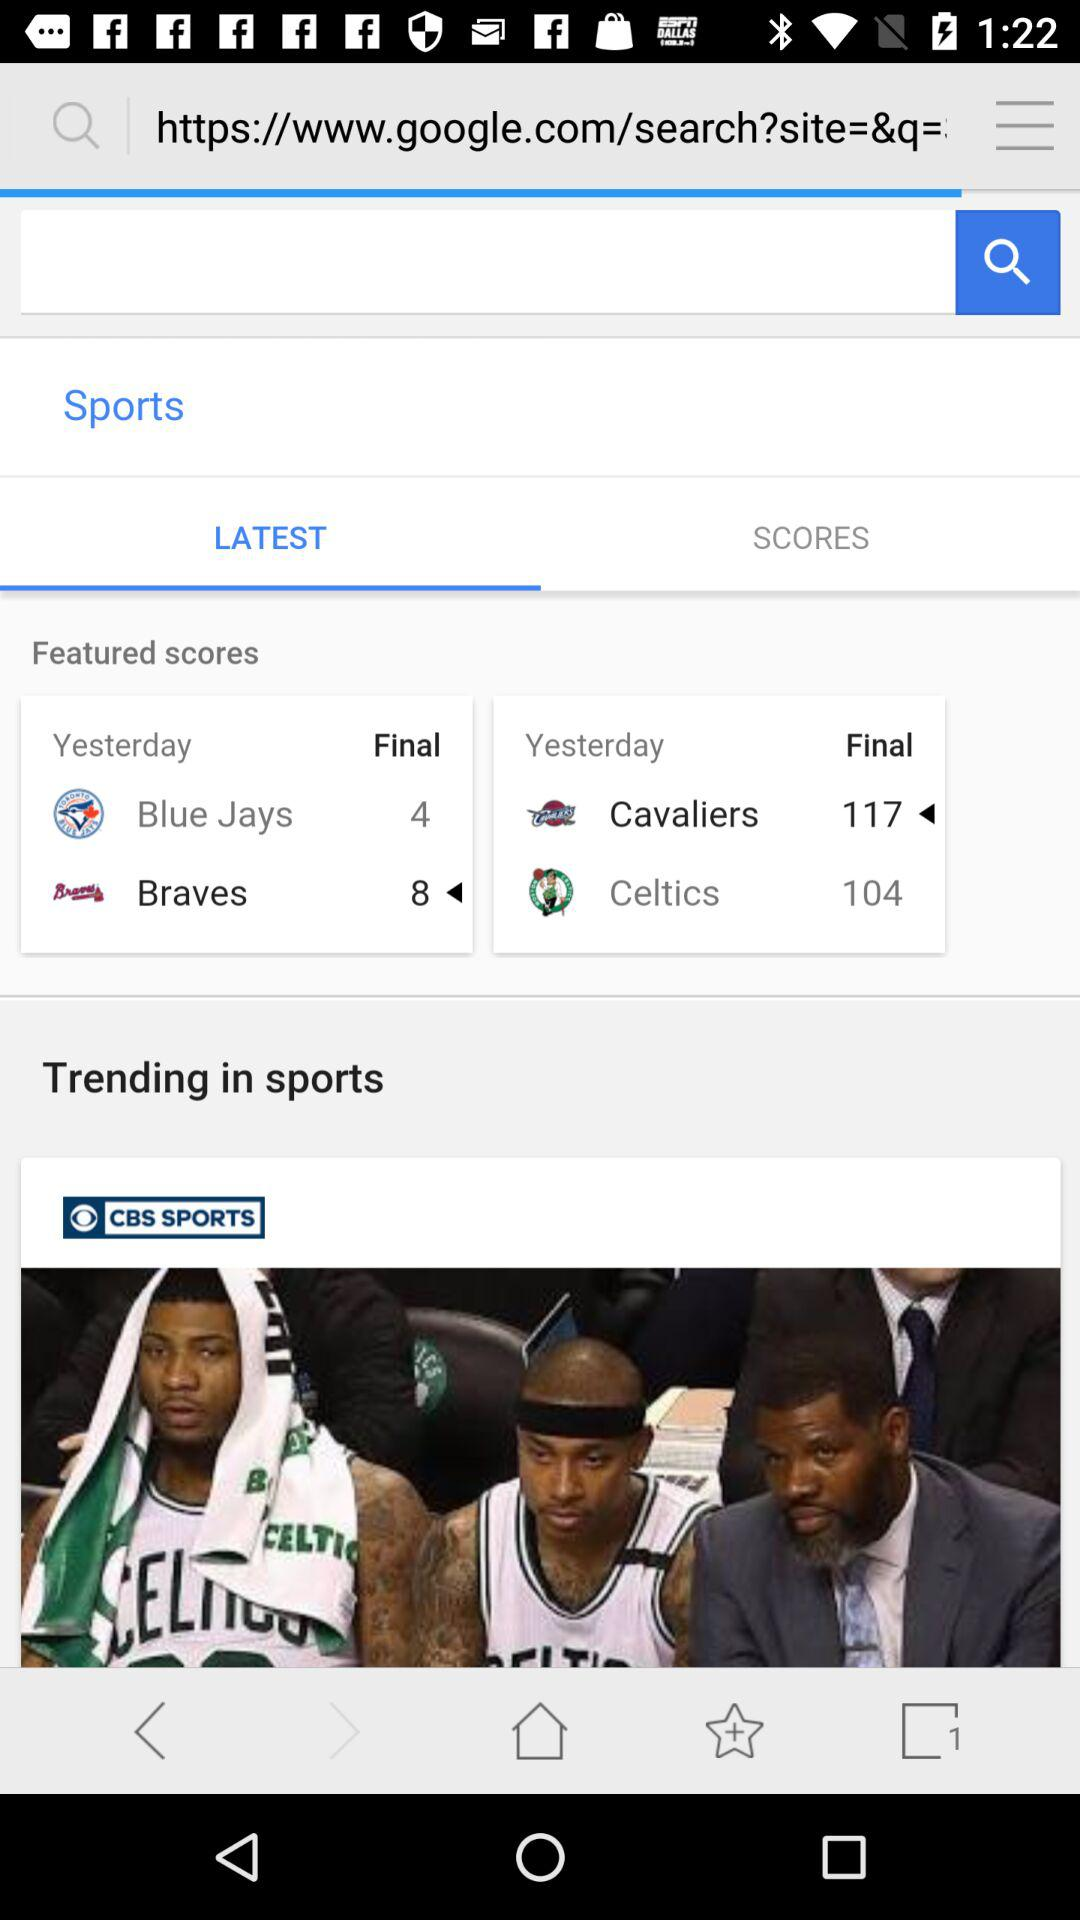How many more points did the Cavaliers score than the Blue Jays?
Answer the question using a single word or phrase. 113 